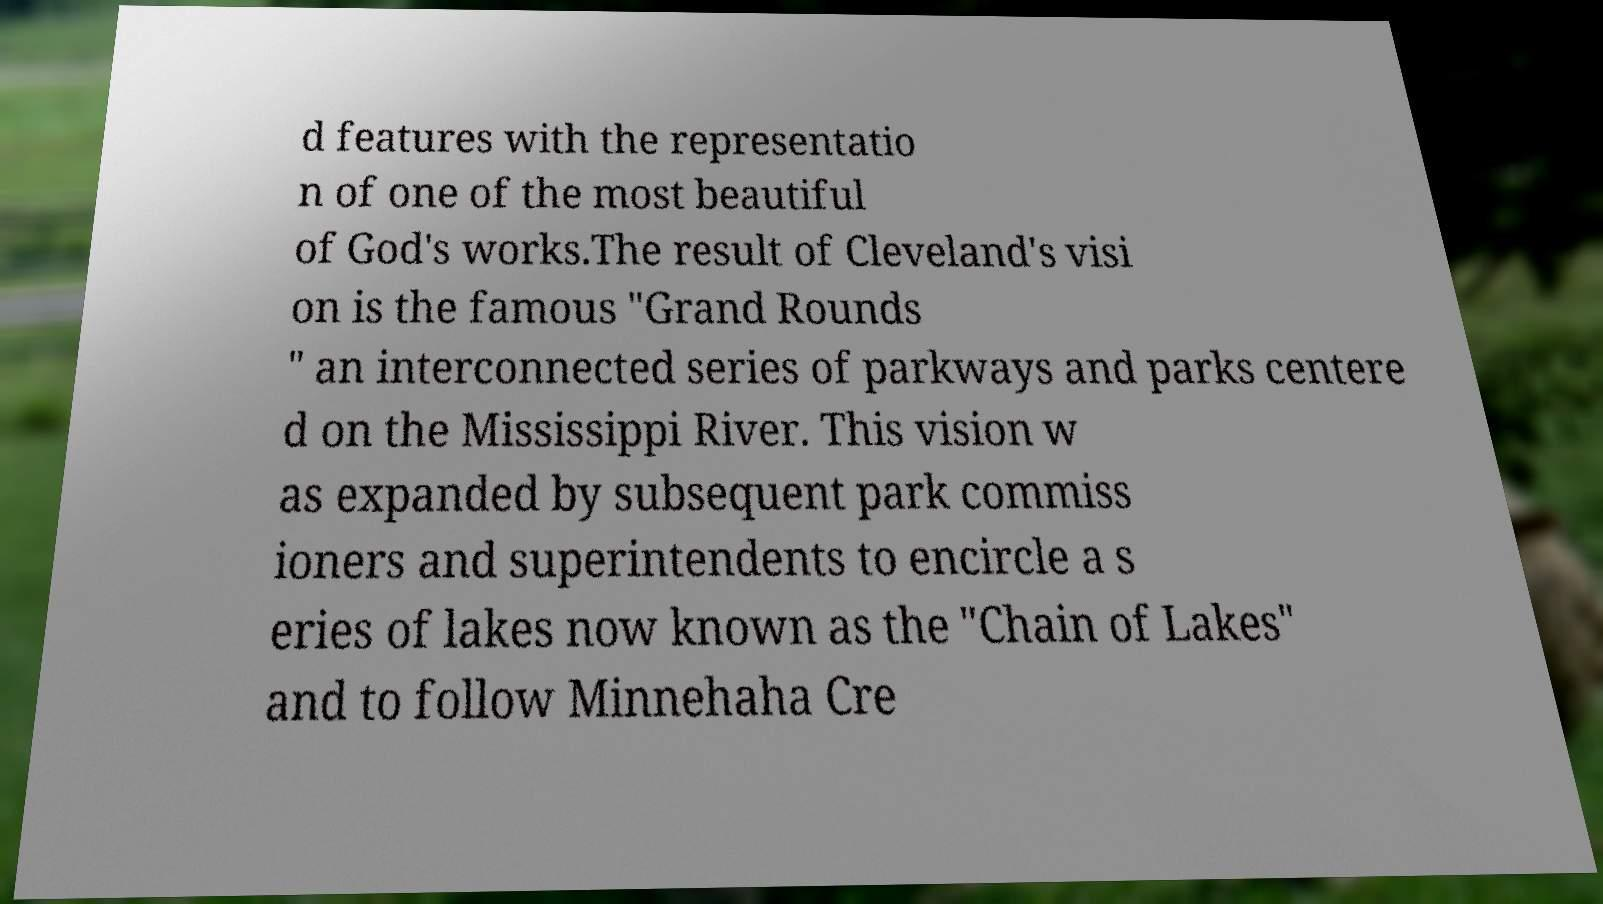There's text embedded in this image that I need extracted. Can you transcribe it verbatim? d features with the representatio n of one of the most beautiful of God's works.The result of Cleveland's visi on is the famous "Grand Rounds " an interconnected series of parkways and parks centere d on the Mississippi River. This vision w as expanded by subsequent park commiss ioners and superintendents to encircle a s eries of lakes now known as the "Chain of Lakes" and to follow Minnehaha Cre 